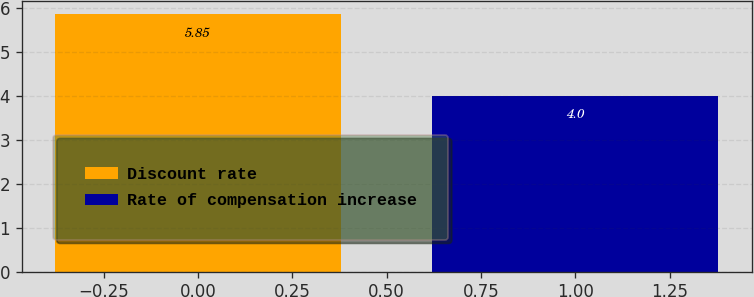Convert chart to OTSL. <chart><loc_0><loc_0><loc_500><loc_500><bar_chart><fcel>Discount rate<fcel>Rate of compensation increase<nl><fcel>5.85<fcel>4<nl></chart> 